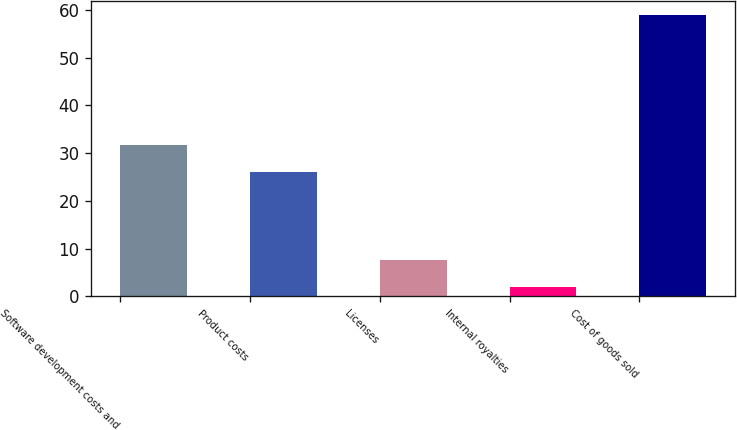Convert chart to OTSL. <chart><loc_0><loc_0><loc_500><loc_500><bar_chart><fcel>Software development costs and<fcel>Product costs<fcel>Licenses<fcel>Internal royalties<fcel>Cost of goods sold<nl><fcel>31.69<fcel>26<fcel>7.69<fcel>2<fcel>58.9<nl></chart> 